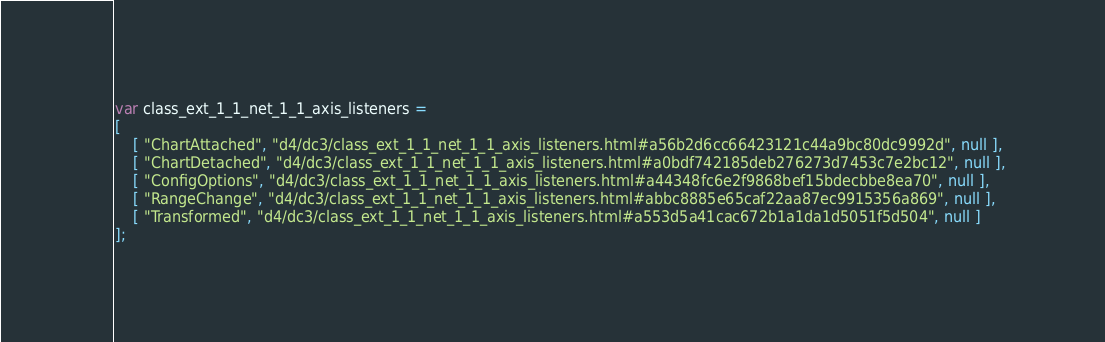Convert code to text. <code><loc_0><loc_0><loc_500><loc_500><_JavaScript_>var class_ext_1_1_net_1_1_axis_listeners =
[
    [ "ChartAttached", "d4/dc3/class_ext_1_1_net_1_1_axis_listeners.html#a56b2d6cc66423121c44a9bc80dc9992d", null ],
    [ "ChartDetached", "d4/dc3/class_ext_1_1_net_1_1_axis_listeners.html#a0bdf742185deb276273d7453c7e2bc12", null ],
    [ "ConfigOptions", "d4/dc3/class_ext_1_1_net_1_1_axis_listeners.html#a44348fc6e2f9868bef15bdecbbe8ea70", null ],
    [ "RangeChange", "d4/dc3/class_ext_1_1_net_1_1_axis_listeners.html#abbc8885e65caf22aa87ec9915356a869", null ],
    [ "Transformed", "d4/dc3/class_ext_1_1_net_1_1_axis_listeners.html#a553d5a41cac672b1a1da1d5051f5d504", null ]
];</code> 